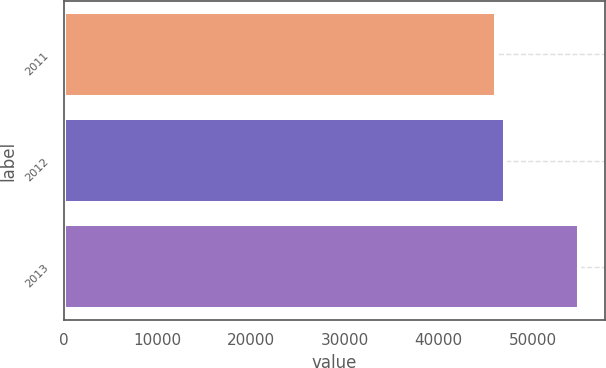Convert chart to OTSL. <chart><loc_0><loc_0><loc_500><loc_500><bar_chart><fcel>2011<fcel>2012<fcel>2013<nl><fcel>46114<fcel>47091<fcel>54980<nl></chart> 